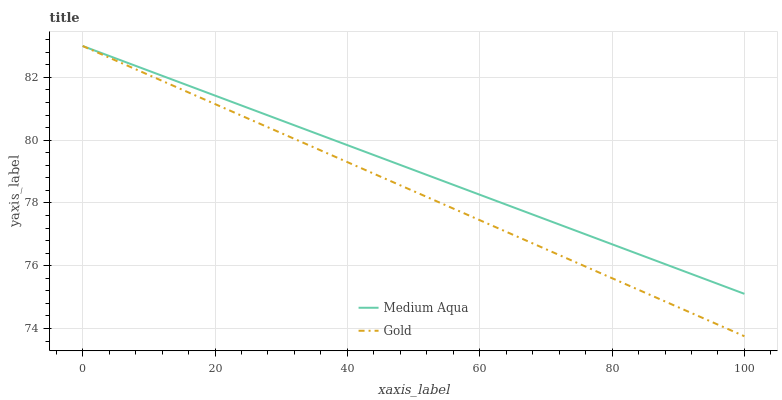Does Gold have the minimum area under the curve?
Answer yes or no. Yes. Does Medium Aqua have the maximum area under the curve?
Answer yes or no. Yes. Does Gold have the maximum area under the curve?
Answer yes or no. No. Is Gold the smoothest?
Answer yes or no. Yes. Is Medium Aqua the roughest?
Answer yes or no. Yes. Is Gold the roughest?
Answer yes or no. No. Does Gold have the lowest value?
Answer yes or no. Yes. Does Gold have the highest value?
Answer yes or no. Yes. Does Medium Aqua intersect Gold?
Answer yes or no. Yes. Is Medium Aqua less than Gold?
Answer yes or no. No. Is Medium Aqua greater than Gold?
Answer yes or no. No. 